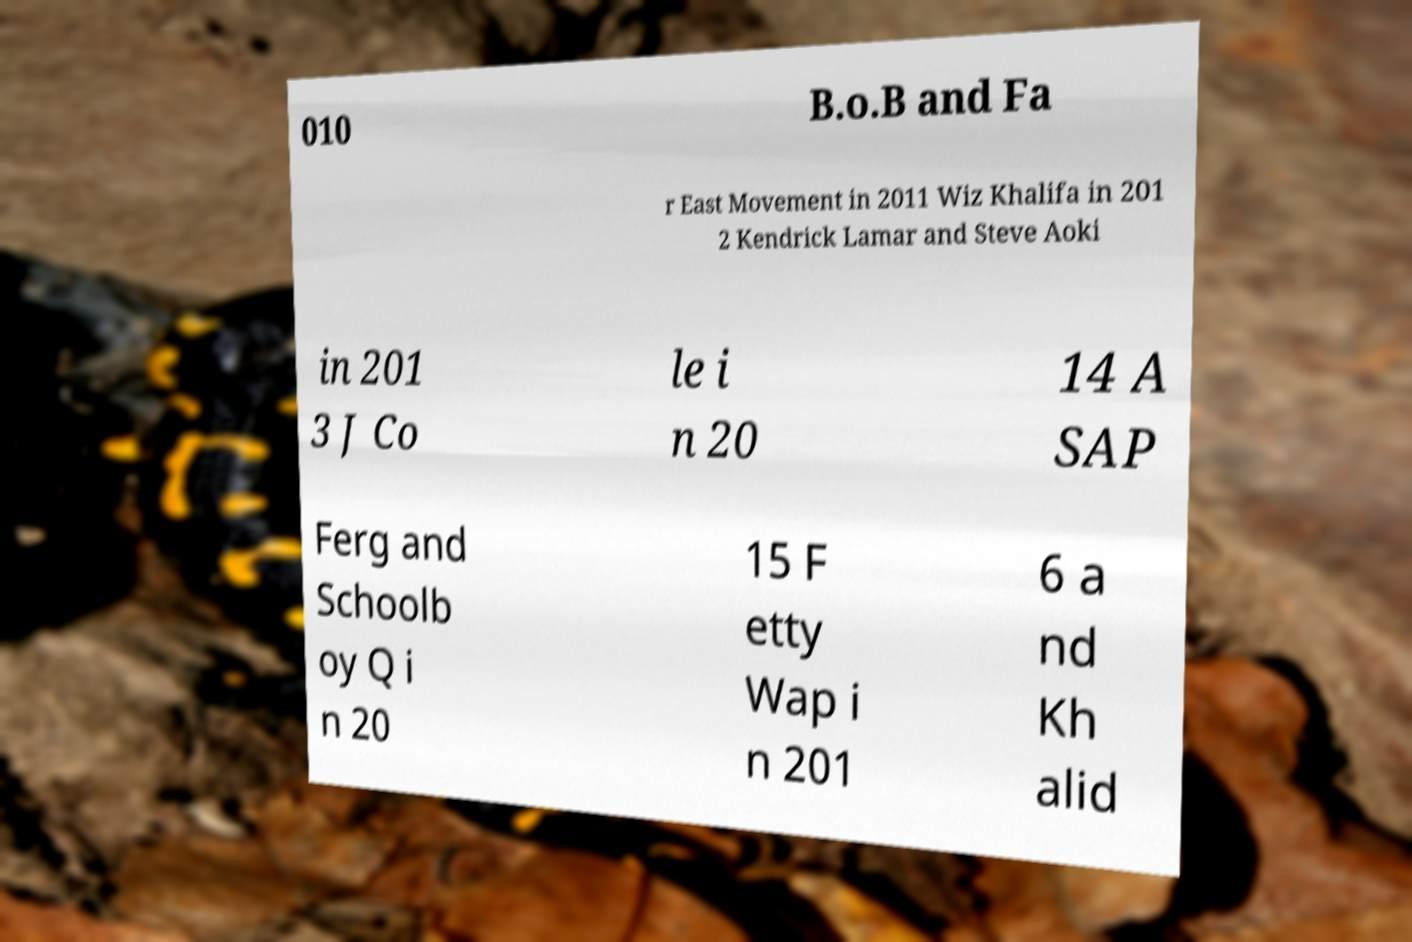Could you assist in decoding the text presented in this image and type it out clearly? 010 B.o.B and Fa r East Movement in 2011 Wiz Khalifa in 201 2 Kendrick Lamar and Steve Aoki in 201 3 J Co le i n 20 14 A SAP Ferg and Schoolb oy Q i n 20 15 F etty Wap i n 201 6 a nd Kh alid 